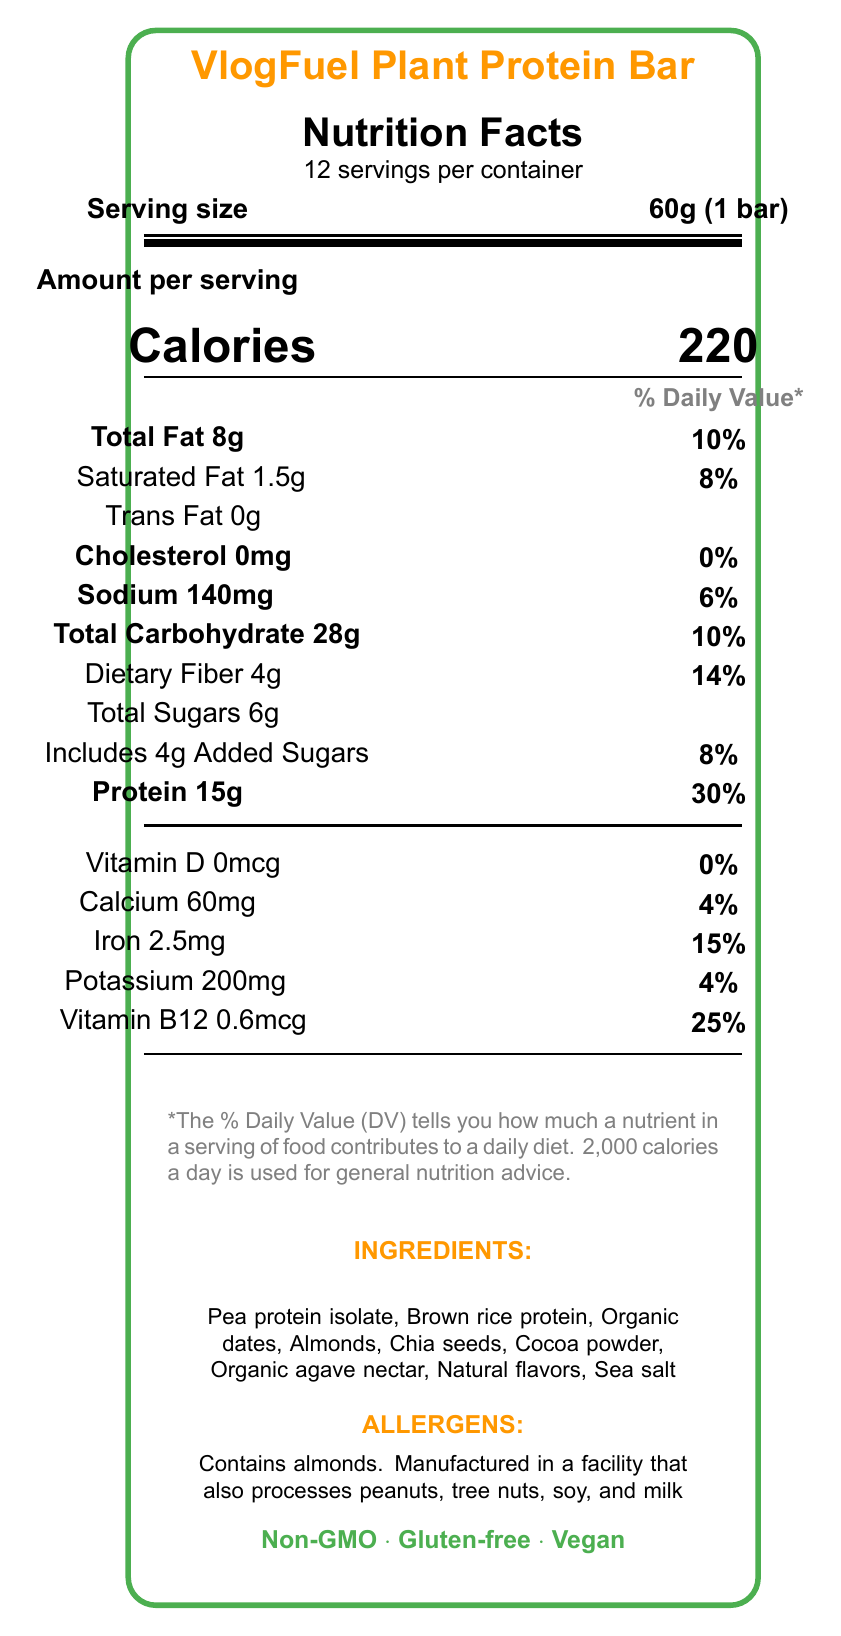what is the product name? The product name is displayed prominently at the top of the document as "VlogFuel Plant Protein Bar".
Answer: VlogFuel Plant Protein Bar how many calories are in one serving? The calories per serving are listed next to the "Calories" label, showing 220.
Answer: 220 what is the serving size for this plant-based protein bar? The serving size is clearly mentioned next to the "Serving size" label, indicating 60g (1 bar).
Answer: 60g (1 bar) how many servings are there per container? The number of servings per container is stated right below the product name and nutrition facts heading as 12.
Answer: 12 what is the total amount of fat per serving? The total amount of fat per serving is listed as "Total Fat 8g" in the nutrition information section.
Answer: 8g what percentage of the Daily Value does 15g of protein represent? The percentage of the Daily Value for protein is shown as 30% next to the "Protein 15g" entry.
Answer: 30% identify the allergen present in the protein bar. The allergens are listed under a specific "ALLERGENS" section, showing clearly that the product contains almonds.
Answer: Contains almonds what is the amount of dietary fiber per serving? The amount of dietary fiber per serving is listed in the nutrition information section as "Dietary Fiber 4g".
Answer: 4g True or False: The plant protein bar contains trans fat. The document specifies "Trans Fat 0g," indicating there are no trans fats.
Answer: False which of the following ingredients is not in the protein bar? A. Pea protein isolate B. Almonds C. Whey protein D. Chia seeds The list of ingredients does not mention whey protein but includes the other options.
Answer: C what percentage of the Daily Value of iron does one serving provide? The percentage of the Daily Value for iron is shown as 15% next to the "Iron 2.5mg" entry.
Answer: 15% describe the main features of this plant-based protein bar. The main features of the protein bar are highlighted as Non-GMO, Gluten-free, Vegan, No artificial sweeteners, and High in fiber in the document.
Answer: Non-GMO, Gluten-free, Vegan, No artificial sweeteners, High in fiber why might this protein bar be suitable for vloggers on the go? The protein bar provides 15g of protein and 4g of fiber per serving, and its portable 60g size makes it convenient for vloggers who need quick, nutritious snacks during their busy schedules.
Answer: High in protein and fiber, convenient serving size how much potassium does each serving of the protein bar contain? The amount of potassium per serving is listed as "Potassium 200mg".
Answer: 200mg what are the social media handles for VlogFuel? A. @vlogfuel, B. VlogFuel Official, C. @vlogfuel_bars, D. All of the above The document lists all three social media handles for Instagram, YouTube, and TikTok.
Answer: D can you tell if the protein bar is gluten-free? The document specifies under features that the protein bar is Gluten-free.
Answer: Yes what is the slogan or brand statement for VlogFuel? The slogan or brand statement is directly included in the document.
Answer: Fuel your creativity with VlogFuel - the ultimate plant-based protein bar for on-the-go content creators! how much calcium does one serving of the protein bar provide? The amount of calcium per serving is listed as "Calcium 60mg".
Answer: 60mg by what date should the protein bar be consumed by? The exact best-before date is not provided in the document, as it says "See packaging for best before date".
Answer: Not enough information how should the protein bar be stored? The storage instructions specify that the protein bar should be stored in a cool, dry place.
Answer: Store in a cool, dry place 